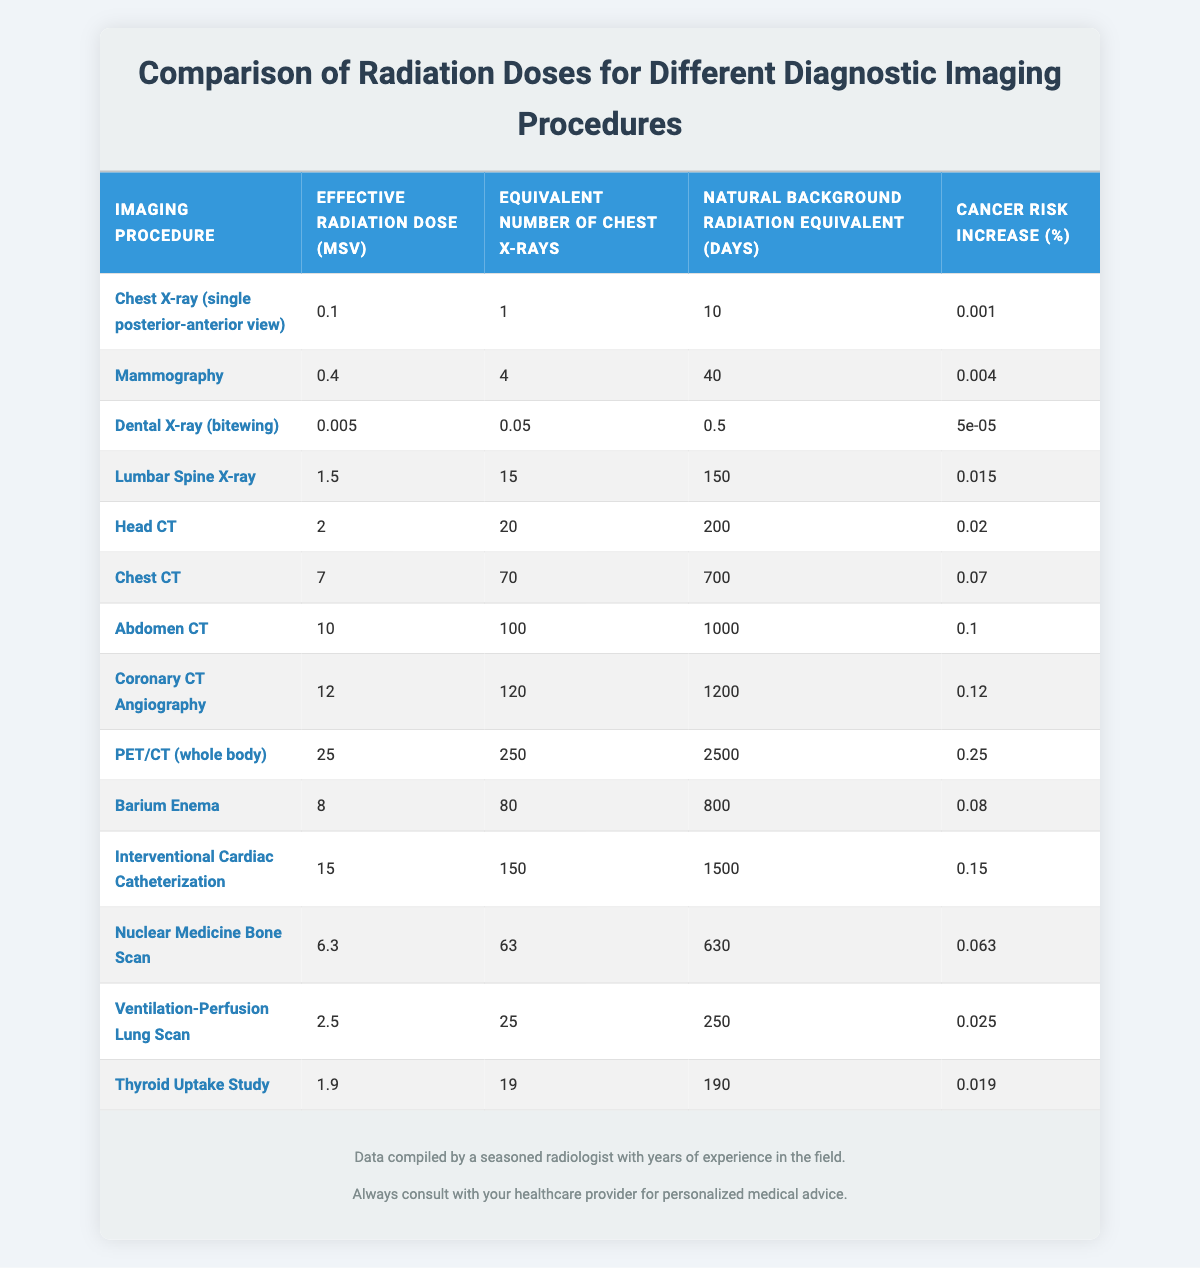What is the effective radiation dose for a Chest X-ray (single posterior-anterior view)? The table lists the effective radiation dose for each imaging procedure. For a Chest X-ray (single posterior-anterior view), the effective radiation dose is specified as 0.1 mSv.
Answer: 0.1 mSv How many equivalent chest X-rays does a PET/CT (whole body) have? According to the table, the equivalent number of chest X-rays for a PET/CT (whole body) is 250 as stated in the column specifically for equivalent chest X-rays.
Answer: 250 Which imaging procedure has the highest cancer risk increase percentage? The cancer risk increase percentage is listed for each procedure in the last column. Scanning the table, it shows that the imaging procedure with the highest percentage is PET/CT (whole body) at 0.25%.
Answer: 0.25% What is the natural background radiation equivalent (in days) for a Coronary CT Angiography? The table provides the natural background radiation equivalent for each imaging type. For Coronary CT Angiography, the equivalent is listed as 1200 days in the respective column.
Answer: 1200 days Is the effective radiation dose for a Dental X-ray greater than that of a Mammography? By comparing the effective radiation doses listed in the table, the Dental X-ray has a dose of 0.005 mSv while Mammography has a dose of 0.4 mSv. Thus, the statement is false.
Answer: No What is the average effective radiation dose for all the imaging procedures listed in the table? To find the average, you first sum the effective radiation doses for all procedures: (0.1 + 0.4 + 0.005 + 1.5 + 2 + 7 + 10 + 12 + 25 + 8 + 15 + 6.3 + 2.5 + 1.9) = 92.8 mSv. There are 14 procedures, so the average is 92.8 mSv / 14 ≈ 6.59 mSv.
Answer: 6.59 mSv How many imaging procedures have an effective radiation dose equal to or greater than 10 mSv? By checking the effective radiation doses listed in the table, the procedures that have values ≥ 10 mSv are Abdomen CT (10 mSv), Coronary CT Angiography (12 mSv), and PET/CT (whole body) (25 mSv). This results in a total of 3 procedures.
Answer: 3 Which imaging procedure shows the least cancer risk increase? The last column indicates the cancer risk increase for each procedure. The lowest value is attributed to the Dental X-ray with a 0.00005% increase in cancer risk.
Answer: Dental X-ray What is the difference in effective radiation dose between a Chest CT and a Head CT? The effective radiation dose for Chest CT is 7 mSv and for Head CT is 2 mSv. The difference is calculated as 7 mSv - 2 mSv = 5 mSv.
Answer: 5 mSv Does a Lumbar Spine X-ray have a higher effective radiation dose than a Barium Enema? The effective radiation dose for Lumbar Spine X-ray is 1.5 mSv, whereas for Barium Enema it is 8 mSv. Since 1.5 mSv < 8 mSv, the statement is false.
Answer: No 